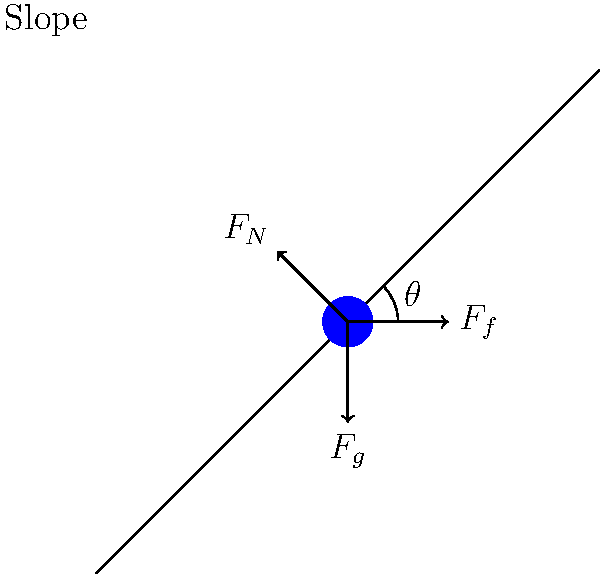As the CEO of an online travel platform specializing in all-inclusive vacation packages, you're considering adding winter sports events to your offerings. To better understand the physics involved in skiing, you're analyzing the forces acting on a skier descending a slope at a constant velocity. If the slope makes an angle $\theta = 30°$ with the horizontal and the coefficient of kinetic friction between the skis and the snow is $\mu_k = 0.1$, what is the magnitude of the normal force $F_N$ acting on a skier with a mass of 70 kg? Let's approach this step-by-step:

1) First, we need to identify the forces acting on the skier:
   - Gravitational force ($F_g$) acting downward
   - Normal force ($F_N$) perpendicular to the slope
   - Friction force ($F_f$) parallel to the slope, opposing motion

2) Since the skier is moving at constant velocity, the net force must be zero. We can break this into components parallel and perpendicular to the slope.

3) For the perpendicular component:
   $F_N - F_g \cos \theta = 0$
   $F_N = F_g \cos \theta = mg \cos \theta$

4) For the parallel component:
   $F_g \sin \theta - F_f = 0$
   $F_f = F_g \sin \theta = mg \sin \theta$

5) We also know that $F_f = \mu_k F_N$ for kinetic friction.

6) Substituting this into the equation from step 4:
   $\mu_k F_N = mg \sin \theta$

7) Now we can solve for $F_N$:
   $F_N = \frac{mg \sin \theta}{\mu_k}$

8) Let's plug in the values:
   $m = 70$ kg
   $g = 9.8$ m/s²
   $\theta = 30°$
   $\mu_k = 0.1$

9) Calculating:
   $F_N = \frac{70 \cdot 9.8 \cdot \sin 30°}{0.1} = 3430$ N

Therefore, the magnitude of the normal force acting on the skier is approximately 3430 N.
Answer: 3430 N 